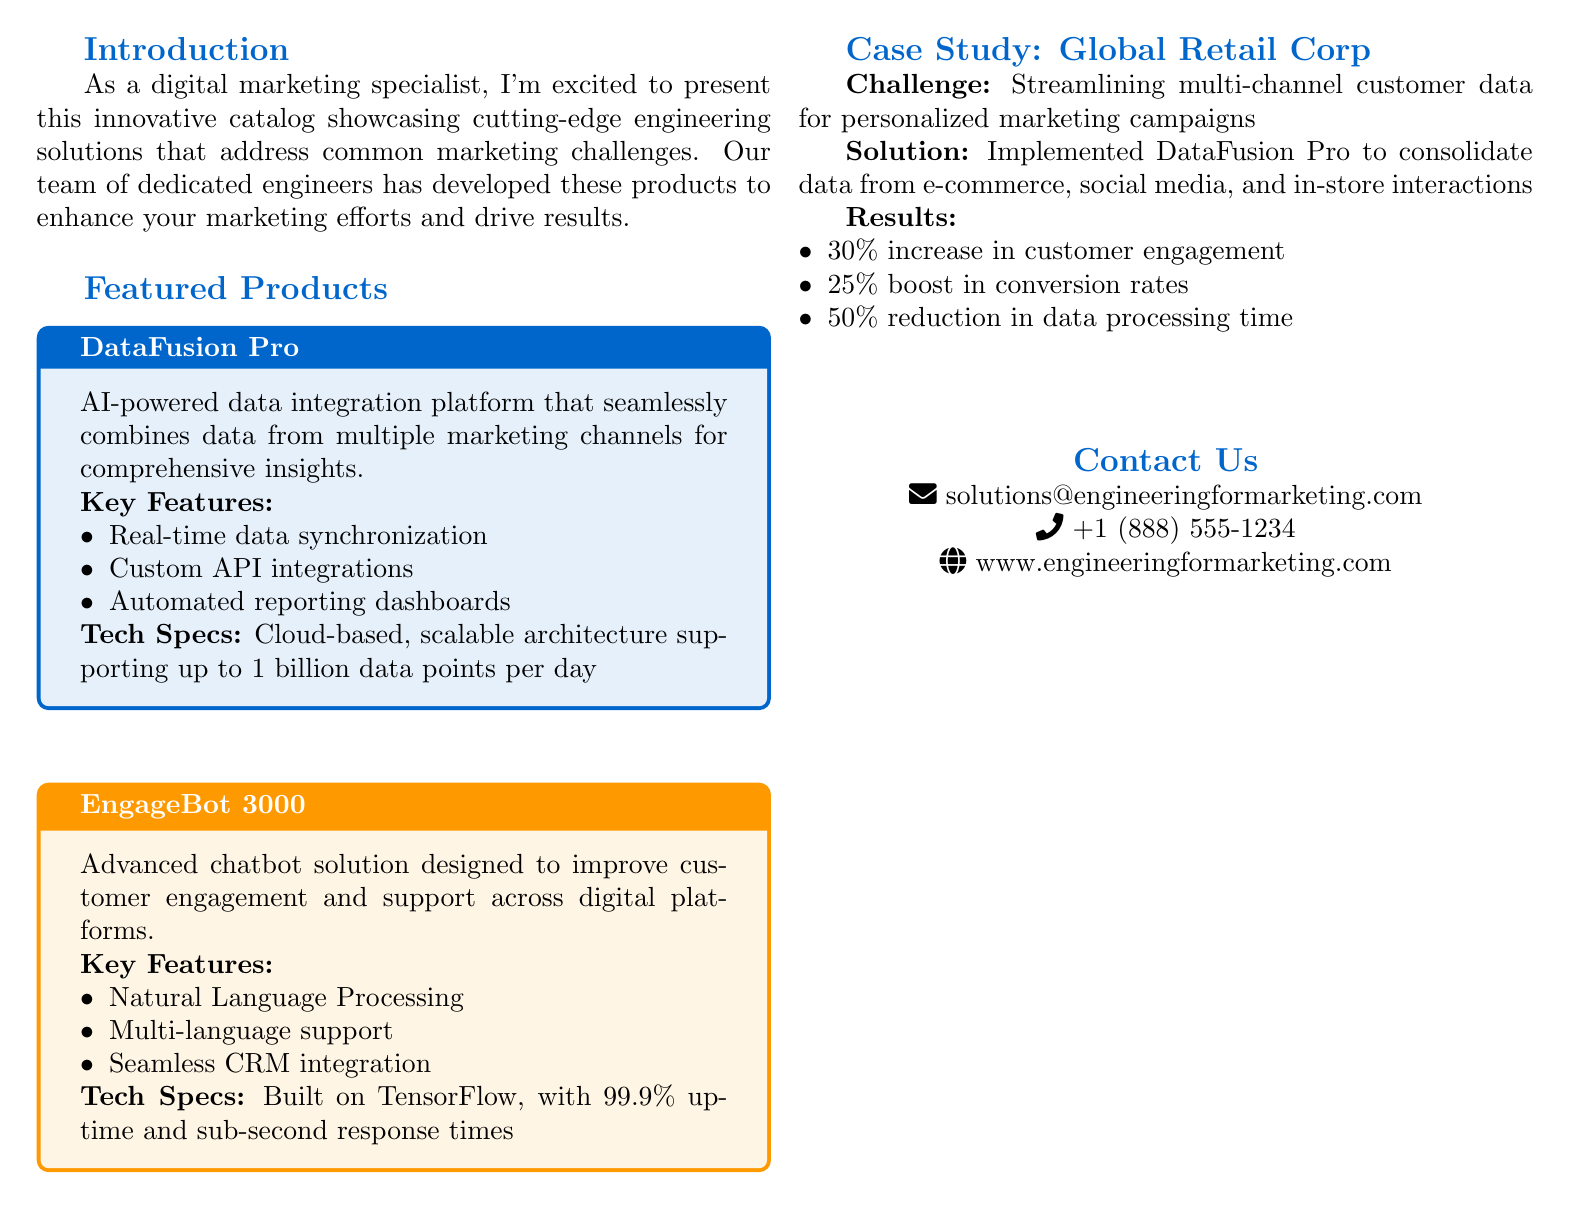What is the title of the catalog? The title of the catalog is provided at the top of the document.
Answer: Engineering Solutions for Marketing Challenges What is the main purpose of DataFusion Pro? The main purpose of DataFusion Pro is described in the featured products section.
Answer: AI-powered data integration platform What company is featured in the case study? The case study helps identify which company is discussed in the document.
Answer: Global Retail Corp What was the percentage increase in customer engagement reported in the case study? This percentage is found in the results of the case study.
Answer: 30% What technology underlies the EngageBot 3000? The technology is mentioned in the technical specifications of the product.
Answer: TensorFlow How many key features does EngageBot 3000 have? The number of features is derived from counting the items listed under key features.
Answer: Three What is the uptime percentage for EngageBot 3000? This detail is included in the technical specifications section.
Answer: 99.9% What is the contact email provided in the document? The contact email is listed under the contact us section of the document.
Answer: solutions@engineeringformarketing.com What benefit did Global Retail Corp achieve regarding data processing time? This benefit is part of the results section of the case study.
Answer: 50% reduction 